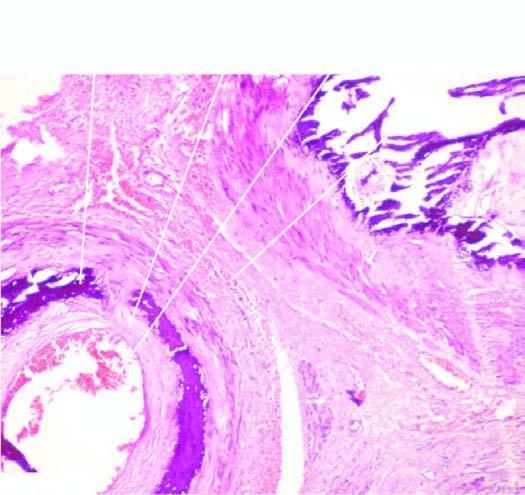what is there calcification exclusively in the tunica media unassociated with?
Answer the question using a single word or phrase. Any significant inflammation 